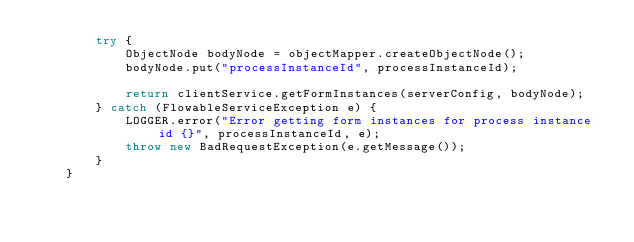Convert code to text. <code><loc_0><loc_0><loc_500><loc_500><_Java_>        try {
            ObjectNode bodyNode = objectMapper.createObjectNode();
            bodyNode.put("processInstanceId", processInstanceId);

            return clientService.getFormInstances(serverConfig, bodyNode);
        } catch (FlowableServiceException e) {
            LOGGER.error("Error getting form instances for process instance id {}", processInstanceId, e);
            throw new BadRequestException(e.getMessage());
        }
    }
    </code> 